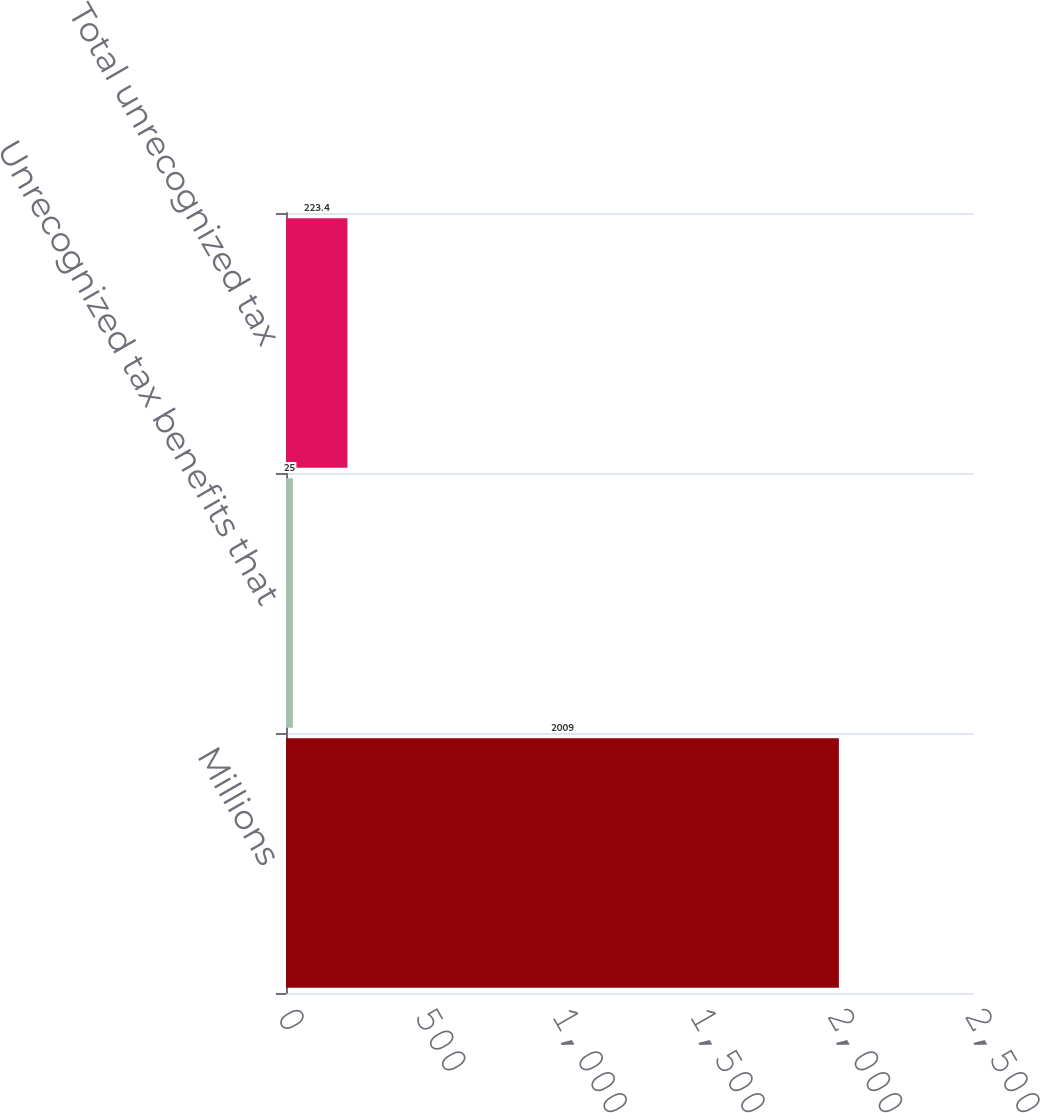Convert chart to OTSL. <chart><loc_0><loc_0><loc_500><loc_500><bar_chart><fcel>Millions<fcel>Unrecognized tax benefits that<fcel>Total unrecognized tax<nl><fcel>2009<fcel>25<fcel>223.4<nl></chart> 